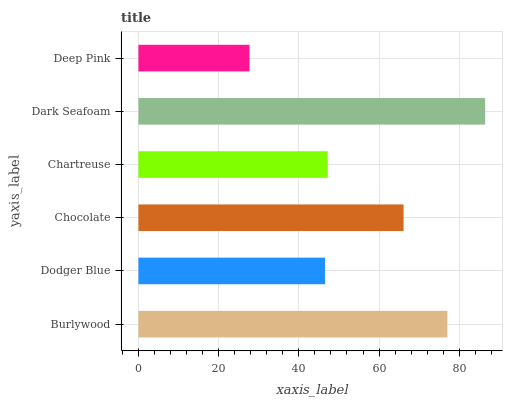Is Deep Pink the minimum?
Answer yes or no. Yes. Is Dark Seafoam the maximum?
Answer yes or no. Yes. Is Dodger Blue the minimum?
Answer yes or no. No. Is Dodger Blue the maximum?
Answer yes or no. No. Is Burlywood greater than Dodger Blue?
Answer yes or no. Yes. Is Dodger Blue less than Burlywood?
Answer yes or no. Yes. Is Dodger Blue greater than Burlywood?
Answer yes or no. No. Is Burlywood less than Dodger Blue?
Answer yes or no. No. Is Chocolate the high median?
Answer yes or no. Yes. Is Chartreuse the low median?
Answer yes or no. Yes. Is Dark Seafoam the high median?
Answer yes or no. No. Is Dark Seafoam the low median?
Answer yes or no. No. 